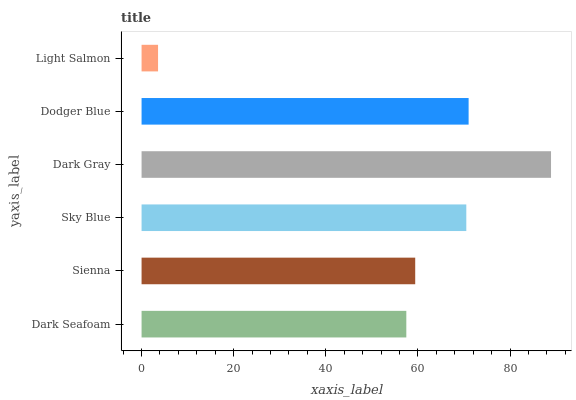Is Light Salmon the minimum?
Answer yes or no. Yes. Is Dark Gray the maximum?
Answer yes or no. Yes. Is Sienna the minimum?
Answer yes or no. No. Is Sienna the maximum?
Answer yes or no. No. Is Sienna greater than Dark Seafoam?
Answer yes or no. Yes. Is Dark Seafoam less than Sienna?
Answer yes or no. Yes. Is Dark Seafoam greater than Sienna?
Answer yes or no. No. Is Sienna less than Dark Seafoam?
Answer yes or no. No. Is Sky Blue the high median?
Answer yes or no. Yes. Is Sienna the low median?
Answer yes or no. Yes. Is Dodger Blue the high median?
Answer yes or no. No. Is Sky Blue the low median?
Answer yes or no. No. 